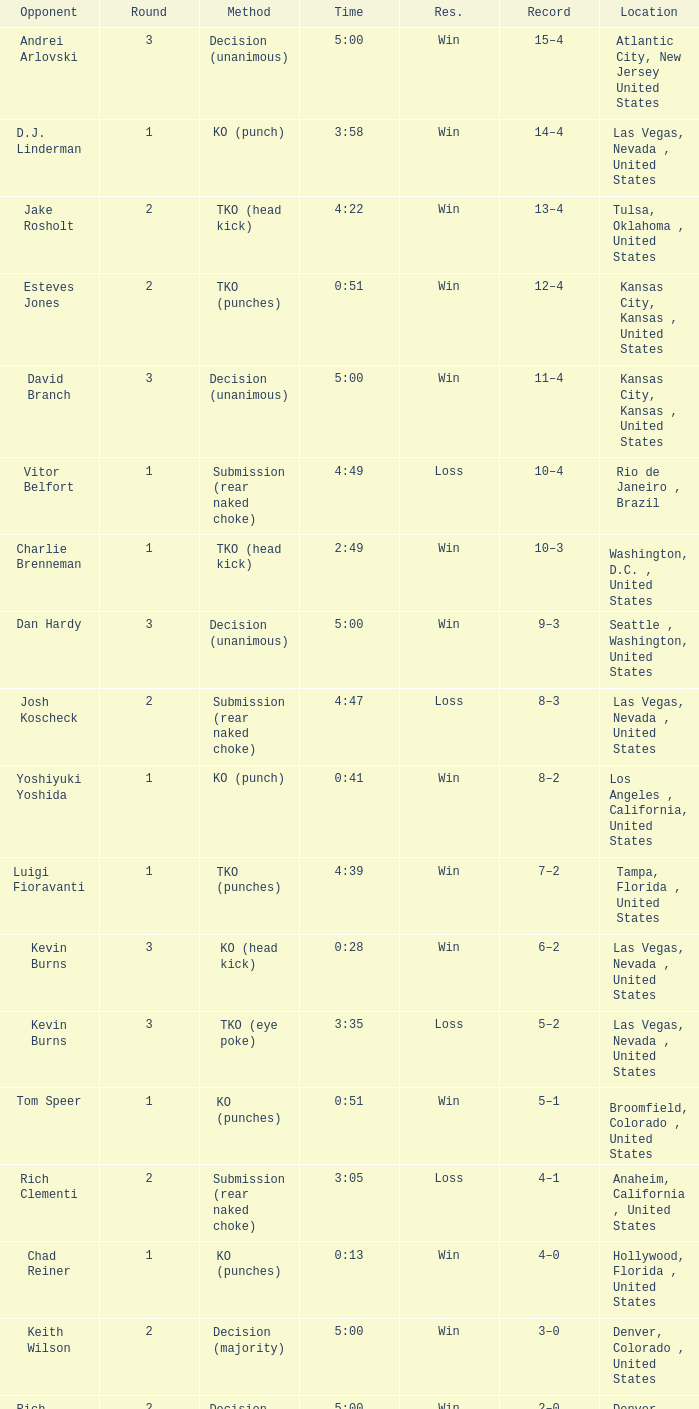What is the result for rounds under 2 against D.J. Linderman? Win. 